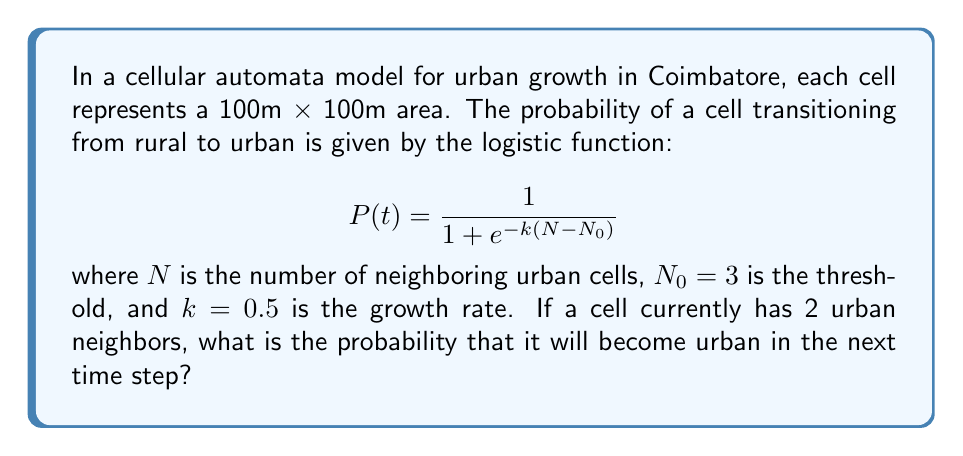Can you answer this question? To solve this problem, we need to follow these steps:

1. Identify the given parameters:
   - $N = 2$ (number of urban neighbors)
   - $N_0 = 3$ (threshold)
   - $k = 0.5$ (growth rate)

2. Substitute these values into the logistic function:

   $$P(t) = \frac{1}{1 + e^{-k(N-N_0)}}$$

3. Calculate $N - N_0$:
   $N - N_0 = 2 - 3 = -1$

4. Multiply $k$ by $(N - N_0)$:
   $k(N - N_0) = 0.5 \times (-1) = -0.5$

5. Calculate $e^{-k(N-N_0)}$:
   $e^{-(-0.5)} = e^{0.5} \approx 1.6487$

6. Add 1 to the result from step 5:
   $1 + e^{0.5} \approx 2.6487$

7. Take the reciprocal of the result from step 6:
   $$P(t) = \frac{1}{2.6487} \approx 0.3775$$

8. Convert to a percentage:
   $0.3775 \times 100\% = 37.75\%$
Answer: 37.75% 